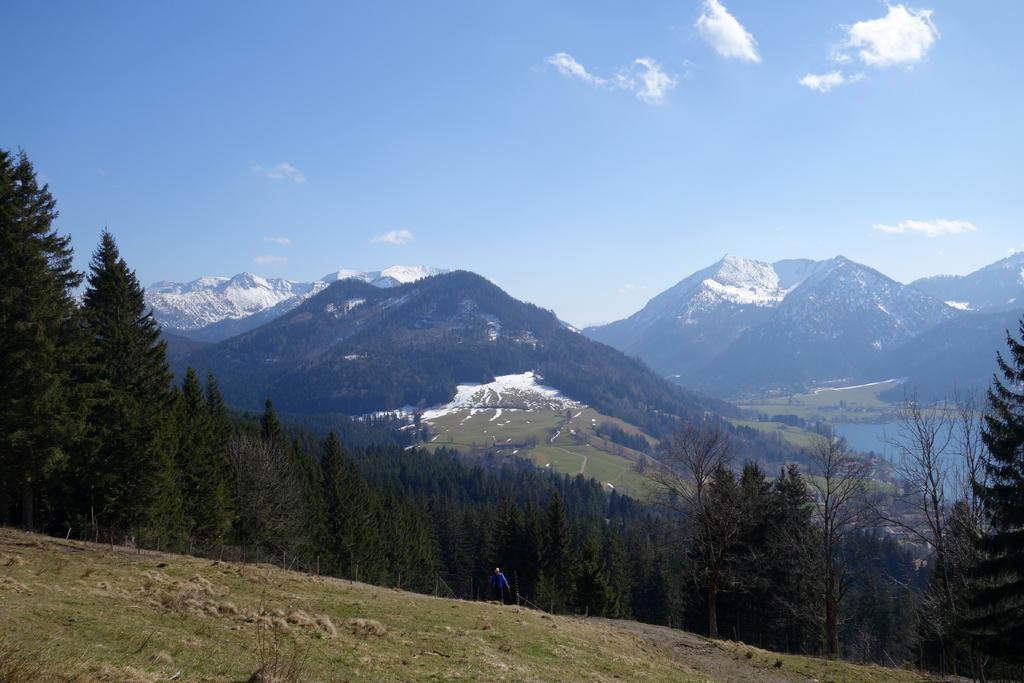Please provide a concise description of this image. In the center of the image we can see the hills. In the background of the image we can see the hills which are covered with snow, trees, water, grass. At the bottom of the image we can see the ground, fence and a person is standing. At the top of the image we can see the clouds in the sky. 